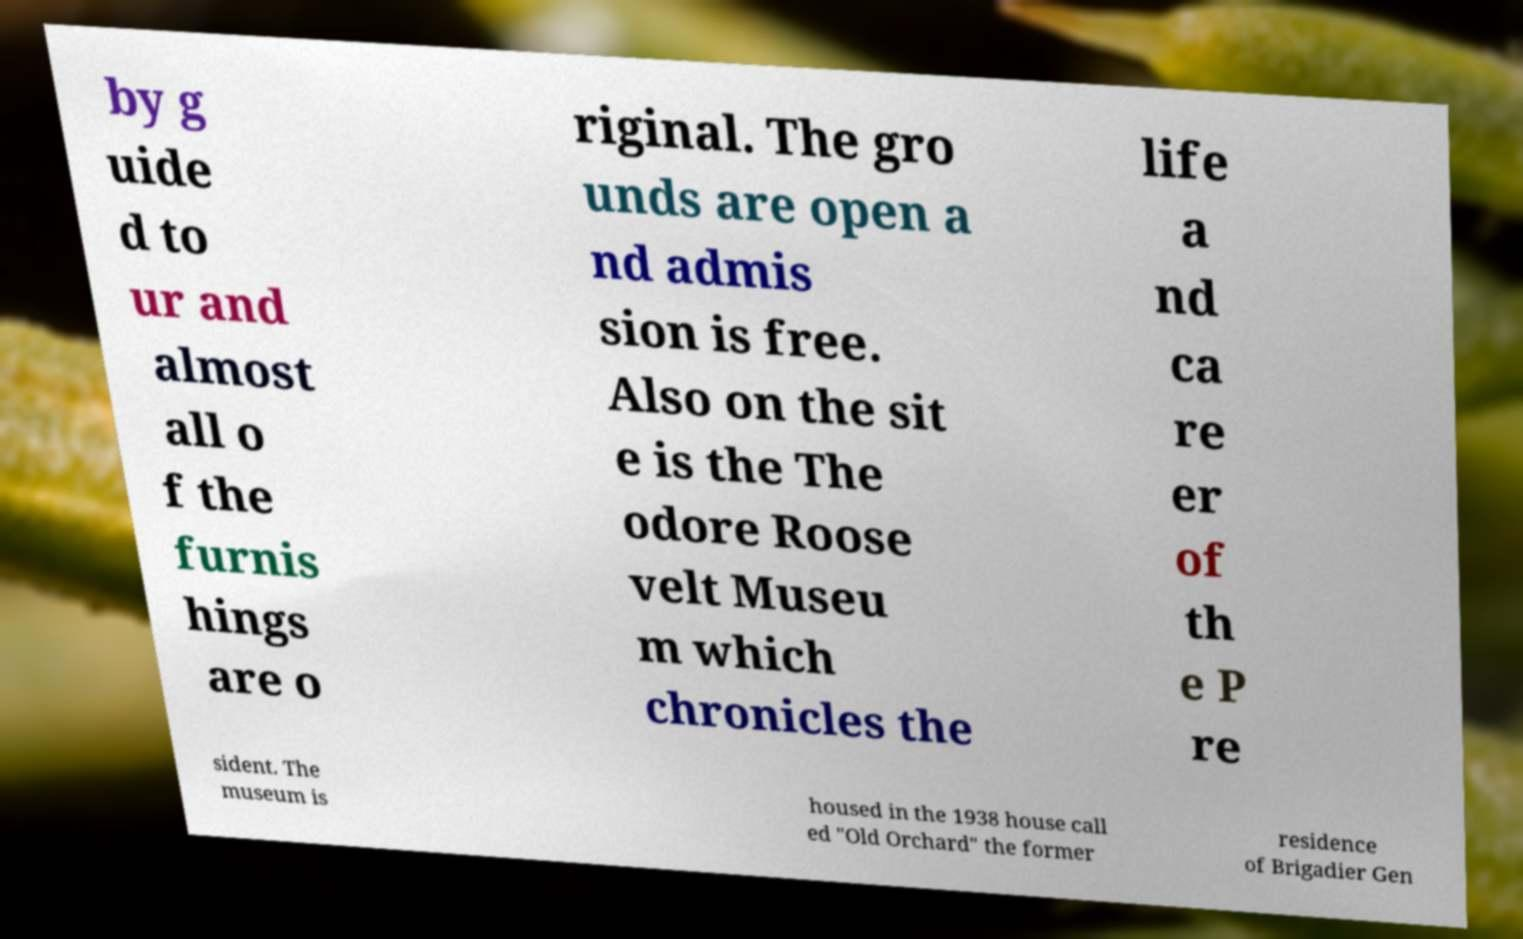Can you accurately transcribe the text from the provided image for me? by g uide d to ur and almost all o f the furnis hings are o riginal. The gro unds are open a nd admis sion is free. Also on the sit e is the The odore Roose velt Museu m which chronicles the life a nd ca re er of th e P re sident. The museum is housed in the 1938 house call ed "Old Orchard" the former residence of Brigadier Gen 